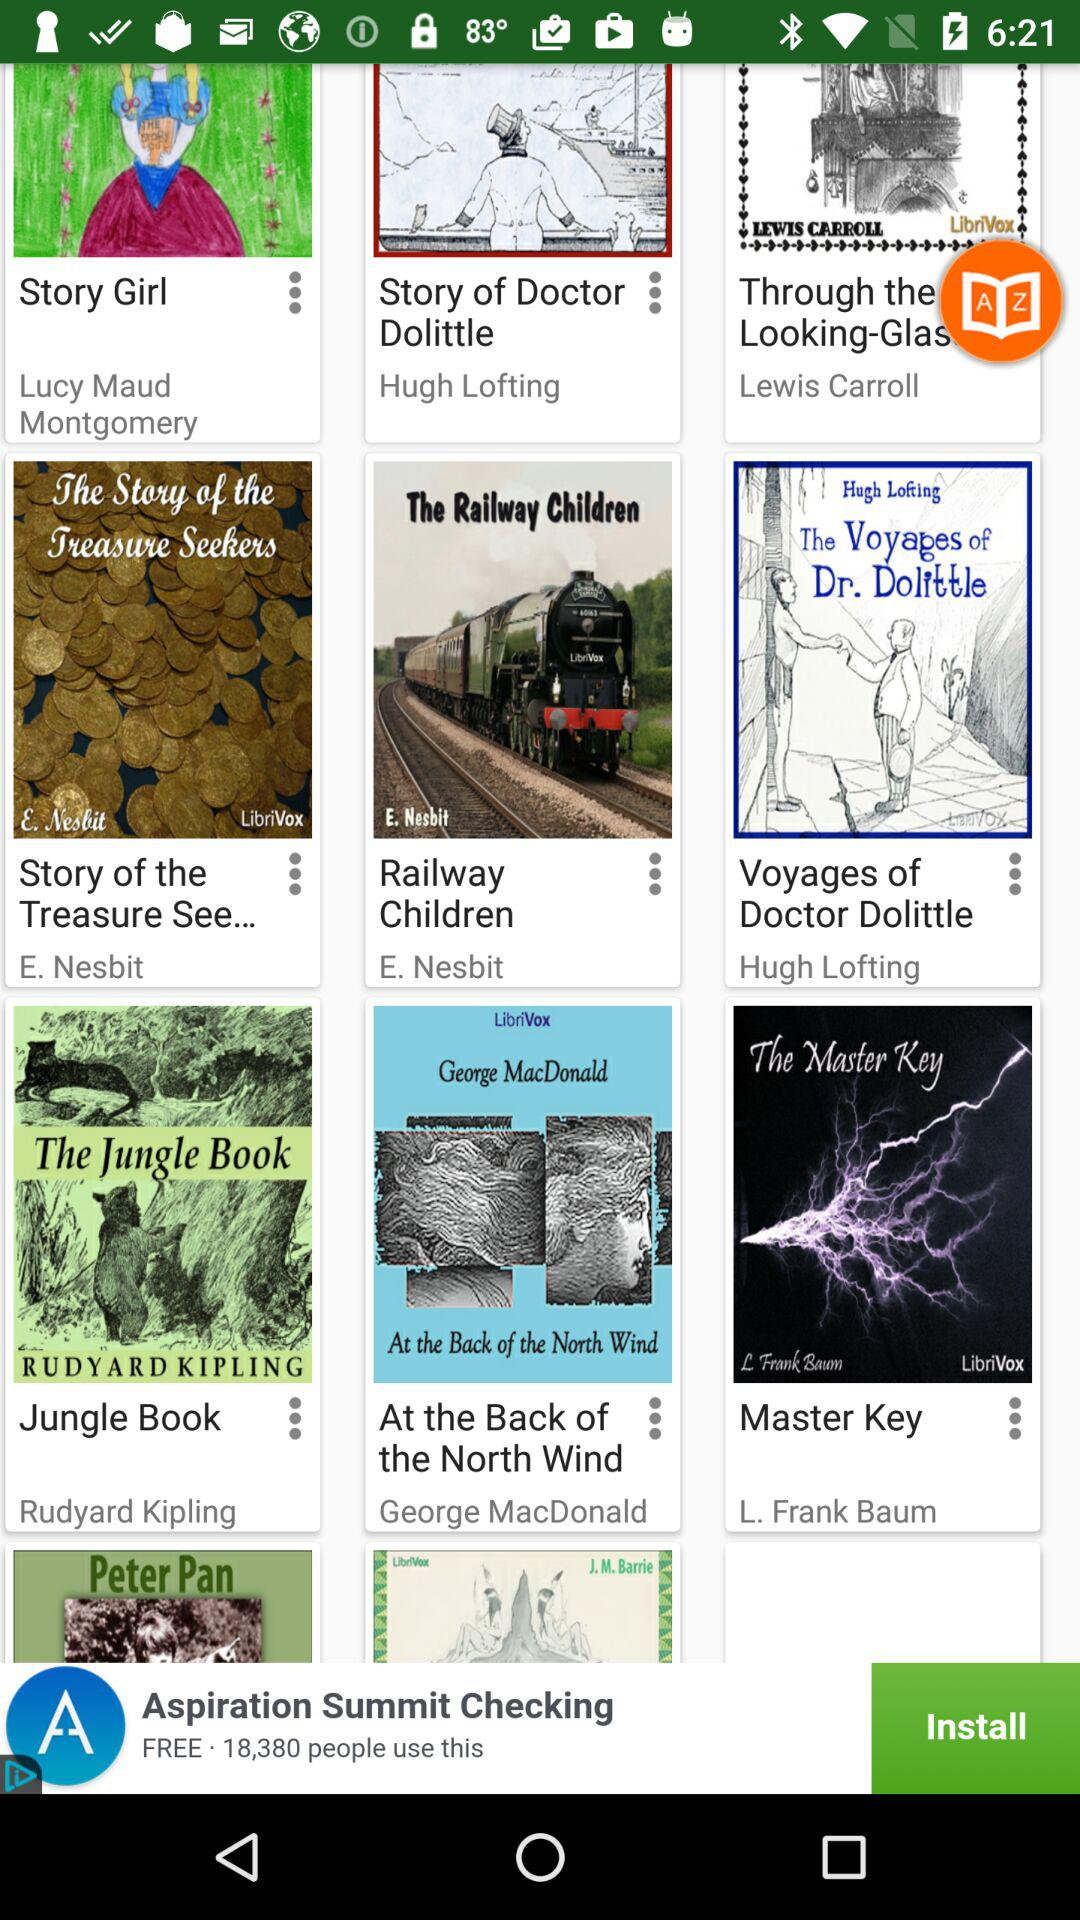Who is the author of the book "Master Key"? The author of the book "Master Key" is L. Frank Baum. 